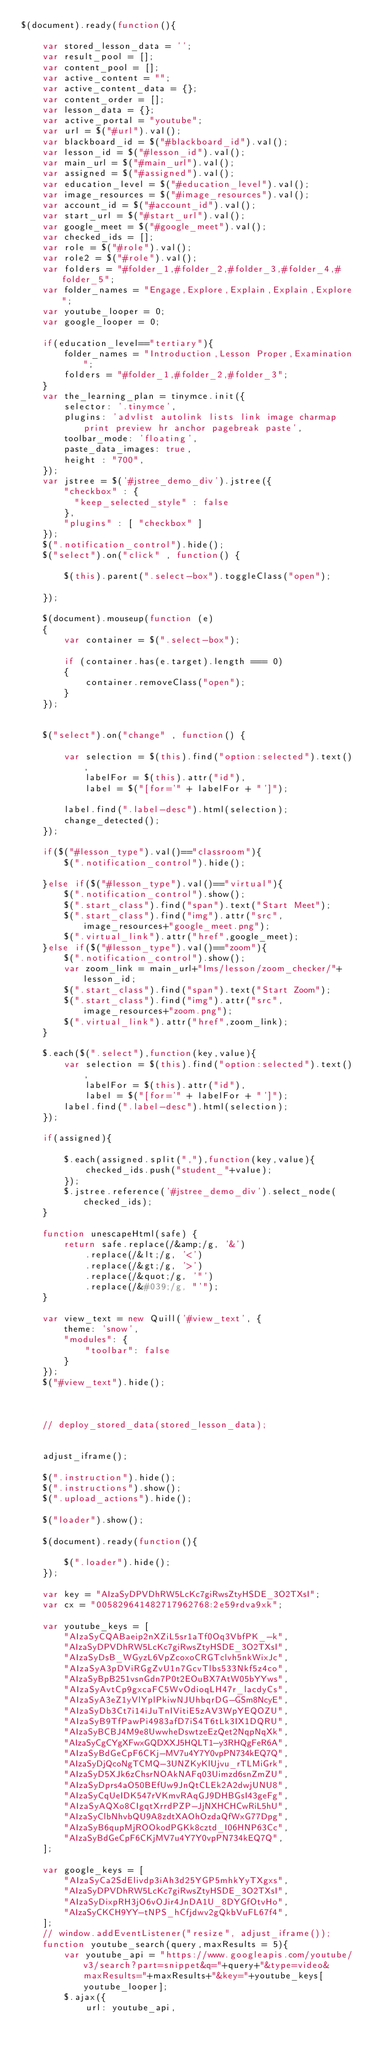<code> <loc_0><loc_0><loc_500><loc_500><_JavaScript_>$(document).ready(function(){

    var stored_lesson_data = '';
    var result_pool = [];
    var content_pool = [];
    var active_content = "";
    var active_content_data = {};
    var content_order = [];
    var lesson_data = {};
    var active_portal = "youtube";
    var url = $("#url").val();
    var blackboard_id = $("#blackboard_id").val();
    var lesson_id = $("#lesson_id").val();
    var main_url = $("#main_url").val();
    var assigned = $("#assigned").val();
    var education_level = $("#education_level").val();
    var image_resources = $("#image_resources").val();
    var account_id = $("#account_id").val();
    var start_url = $("#start_url").val();
    var google_meet = $("#google_meet").val();
    var checked_ids = [];
    var role = $("#role").val();
    var role2 = $("#role").val();
    var folders = "#folder_1,#folder_2,#folder_3,#folder_4,#folder_5";
    var folder_names = "Engage,Explore,Explain,Explain,Explore";
    var youtube_looper = 0;
    var google_looper = 0;

    if(education_level=="tertiary"){
        folder_names = "Introduction,Lesson Proper,Examination";
        folders = "#folder_1,#folder_2,#folder_3";
    }
    var the_learning_plan = tinymce.init({
        selector: '.tinymce',
        plugins: 'advlist autolink lists link image charmap print preview hr anchor pagebreak paste',
        toolbar_mode: 'floating',
        paste_data_images: true,
        height : "700",
    });
    var jstree = $('#jstree_demo_div').jstree({
        "checkbox" : {
          "keep_selected_style" : false
        },
        "plugins" : [ "checkbox" ]
    });
    $(".notification_control").hide();
    $("select").on("click" , function() {
  
        $(this).parent(".select-box").toggleClass("open");
      
    });

    $(document).mouseup(function (e)
    {
        var container = $(".select-box");

        if (container.has(e.target).length === 0)
        {
            container.removeClass("open");
        }
    });


    $("select").on("change" , function() {
        
        var selection = $(this).find("option:selected").text(),
            labelFor = $(this).attr("id"),
            label = $("[for='" + labelFor + "']");

        label.find(".label-desc").html(selection);
        change_detected();
    });

    if($("#lesson_type").val()=="classroom"){
        $(".notification_control").hide();

    }else if($("#lesson_type").val()=="virtual"){
        $(".notification_control").show();
        $(".start_class").find("span").text("Start Meet");
        $(".start_class").find("img").attr("src",image_resources+"google_meet.png");
        $(".virtual_link").attr("href",google_meet);
    }else if($("#lesson_type").val()=="zoom"){
        $(".notification_control").show();
        var zoom_link = main_url+"lms/lesson/zoom_checker/"+lesson_id;
        $(".start_class").find("span").text("Start Zoom");
        $(".start_class").find("img").attr("src",image_resources+"zoom.png");
        $(".virtual_link").attr("href",zoom_link);
    }

    $.each($(".select"),function(key,value){
        var selection = $(this).find("option:selected").text(),
            labelFor = $(this).attr("id"),
            label = $("[for='" + labelFor + "']");
        label.find(".label-desc").html(selection);
    });

    if(assigned){

        $.each(assigned.split(","),function(key,value){
            checked_ids.push("student_"+value);
        });
        $.jstree.reference('#jstree_demo_div').select_node(checked_ids);
    }

    function unescapeHtml(safe) {
        return safe.replace(/&amp;/g, '&')
            .replace(/&lt;/g, '<')
            .replace(/&gt;/g, '>')
            .replace(/&quot;/g, '"')
            .replace(/&#039;/g, "'");
    }

    var view_text = new Quill('#view_text', {
        theme: 'snow',
        "modules": {
            "toolbar": false
        }
    });
    $("#view_text").hide();


    
    // deploy_stored_data(stored_lesson_data);


    adjust_iframe();

    $(".instruction").hide();
    $(".instructions").show();
    $(".upload_actions").hide();

    $("loader").show();

    $(document).ready(function(){

        $(".loader").hide();
    });

    var key = "AIzaSyDPVDhRW5LcKc7giRwsZtyHSDE_3O2TXsI";
    var cx = "005829641482717962768:2e59rdva9xk";

    var youtube_keys = [
        "AIzaSyCQABaeip2nXZiL5sr1aTf0Oq3VbfPK_-k",
        "AIzaSyDPVDhRW5LcKc7giRwsZtyHSDE_3O2TXsI",
        "AIzaSyDsB_WGyzL6VpZcoxoCRGTclvh5nkWixJc",
        "AIzaSyA3pDViRGgZvU1n7GcvTlbs533Nkf5z4co",
        "AIzaSyBpB251vsnGdn7P0t2EOuBX7AtW05bYYws",
        "AIzaSyAvtCp9gxcaFC5WvOdioqLH47r_lacdyCs",
        "AIzaSyA3eZ1yVlYplPkiwNJUhbqrDG-GSm8NcyE",
        "AIzaSyDb3Ct7i14iJuTnIVitiE5zAV3WpYEQOZU",
        "AIzaSyB9TfPawPi4983afD7iS4T6tLk3IX1DQRU",
        "AIzaSyBCBJ4M9e8UwwheDswtzeEzQet2NqpNqXk",
        "AIzaSyCgCYgXFwxGQDXXJ5HQLT1-y3RHQgFeR6A",
        "AIzaSyBdGeCpF6CKj-MV7u4Y7Y0vpPN734kEQ7Q",
        "AIzaSyDjQcoNgTCMQ-3UNZKyKlUjvu_rTLMiGrk",
        "AIzaSyD5XJk6zChsrNOAkNAFq03Uimzd6snZmZU",
        "AIzaSyDprs4aO50BEfUw9JnQtCLEk2A2dwjUNU8",
        "AIzaSyCqUeIDK547rVKmvRAqGJ9DHBGsI43geFg",
        "AIzaSyAQXo8CIgqtXrrdPZP-JjNXHCHCwRiL5hU",
        "AIzaSyClbNhvbQU9A8zdtXAOhOzdaQfWxG77Dpg",
        "AIzaSyB6qupMjROOkodPGKk8cztd_I06HNP63Cc",
        "AIzaSyBdGeCpF6CKjMV7u4Y7Y0vpPN734kEQ7Q",
    ];

    var google_keys = [
        "AIzaSyCa2SdElivdp3iAh3d25YGP5mhkYyTXgxs",
        "AIzaSyDPVDhRW5LcKc7giRwsZtyHSDE_3O2TXsI",
        "AIzaSyDixpRH3jO6vOJir4JnDA1U_8DYGfOtvHo",
        "AIzaSyCKCH9YY-tNPS_hCfjdwv2gQkbVuFL67f4",
    ];
    // window.addEventListener("resize", adjust_iframe());
    function youtube_search(query,maxResults = 5){
        var youtube_api = "https://www.googleapis.com/youtube/v3/search?part=snippet&q="+query+"&type=video&maxResults="+maxResults+"&key="+youtube_keys[youtube_looper];
        $.ajax({
            url: youtube_api,</code> 